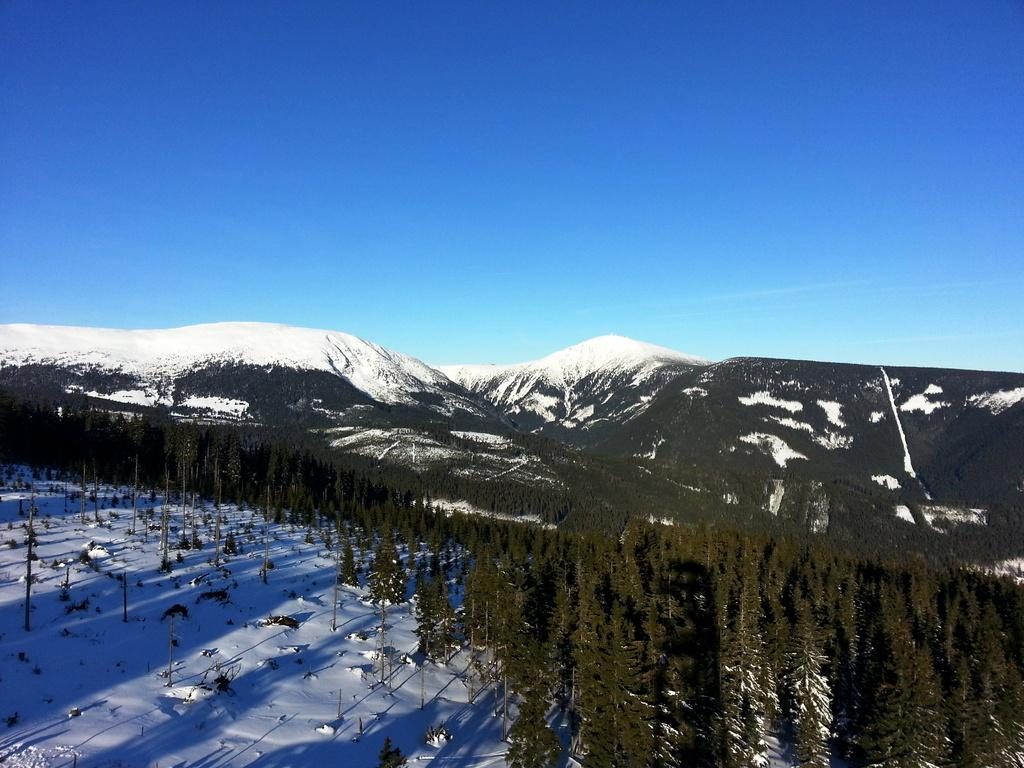What is the main subject of the image? The main subject of the image is a mountain. Are there multiple mountains in the image? Yes, there are mountains in the image. What is visible at the top of the image? The sky is visible at the top of the image. What is the condition of the ground at the bottom of the image? There is snow at the bottom of the image. Who is the owner of the mountain in the image? There is no owner of the mountain in the image, as mountains are natural landforms and not owned by individuals. Can you see a road leading up to the mountain in the image? There is no road visible in the image; it only shows the mountain, trees, sky, and snow. 